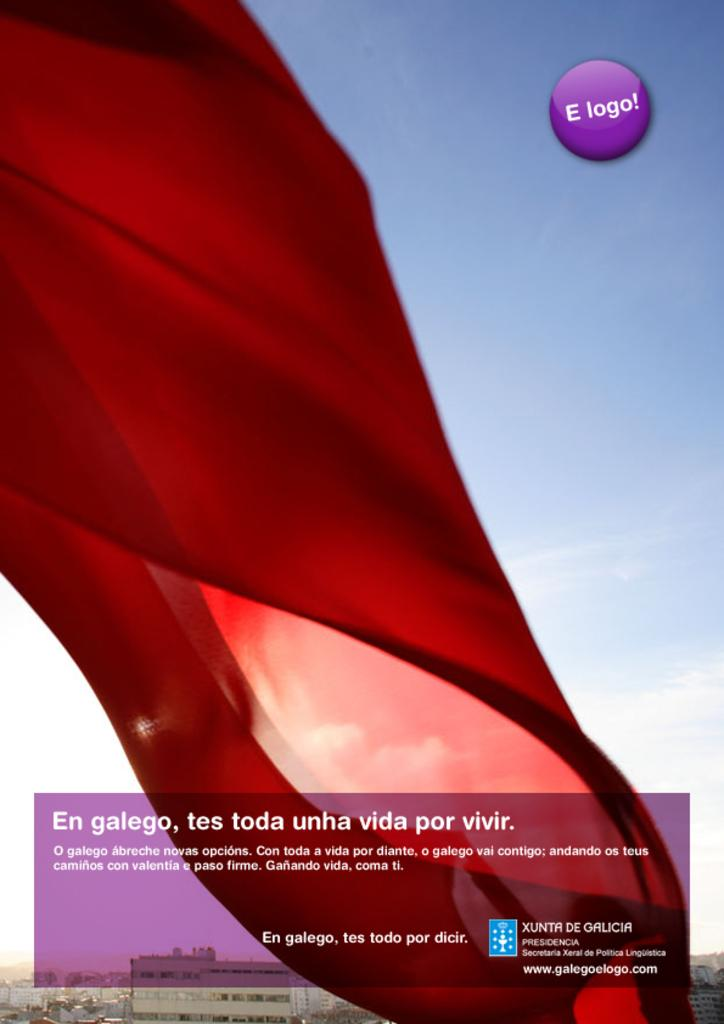<image>
Write a terse but informative summary of the picture. red cloth waving against blue sky and near top a purple circle with E logo! in it 